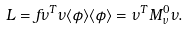<formula> <loc_0><loc_0><loc_500><loc_500>L = f \nu ^ { T } \nu \langle \phi \rangle \langle \phi \rangle = \nu ^ { T } M _ { \nu } ^ { 0 } \nu .</formula> 